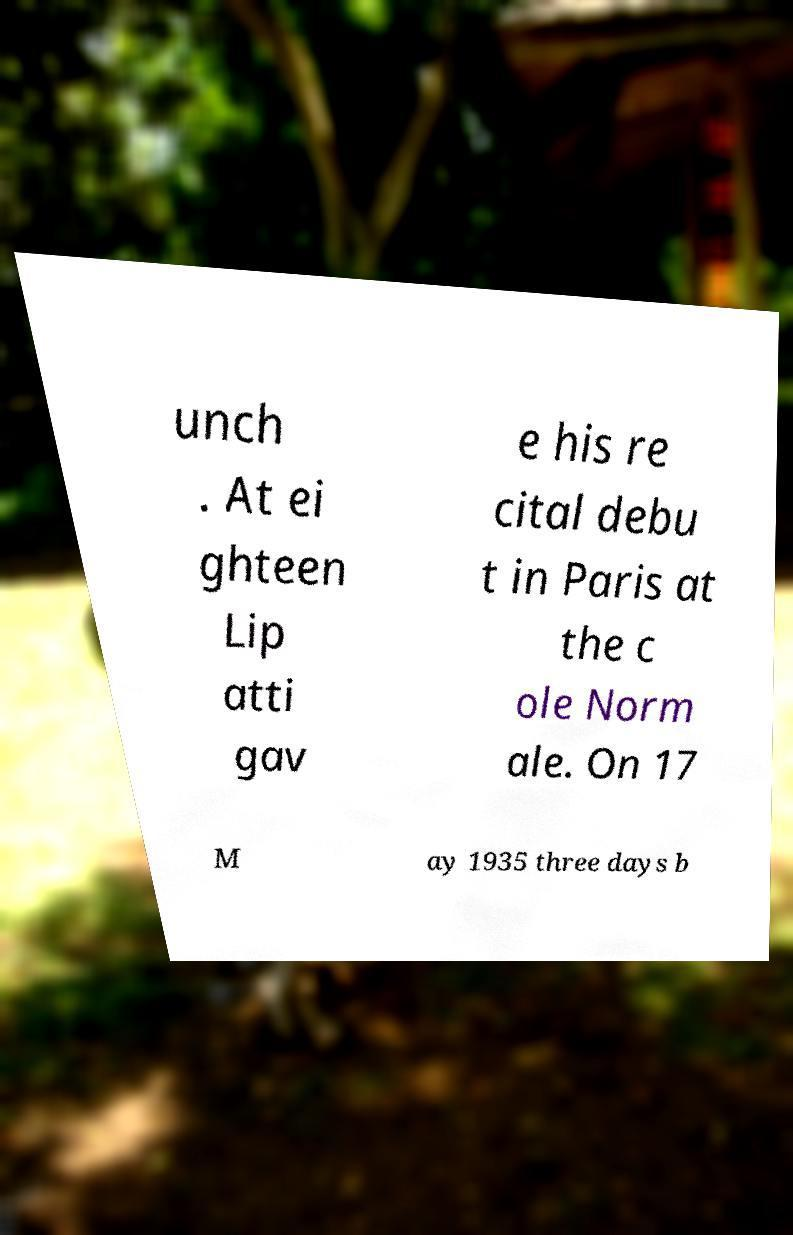Could you assist in decoding the text presented in this image and type it out clearly? unch . At ei ghteen Lip atti gav e his re cital debu t in Paris at the c ole Norm ale. On 17 M ay 1935 three days b 